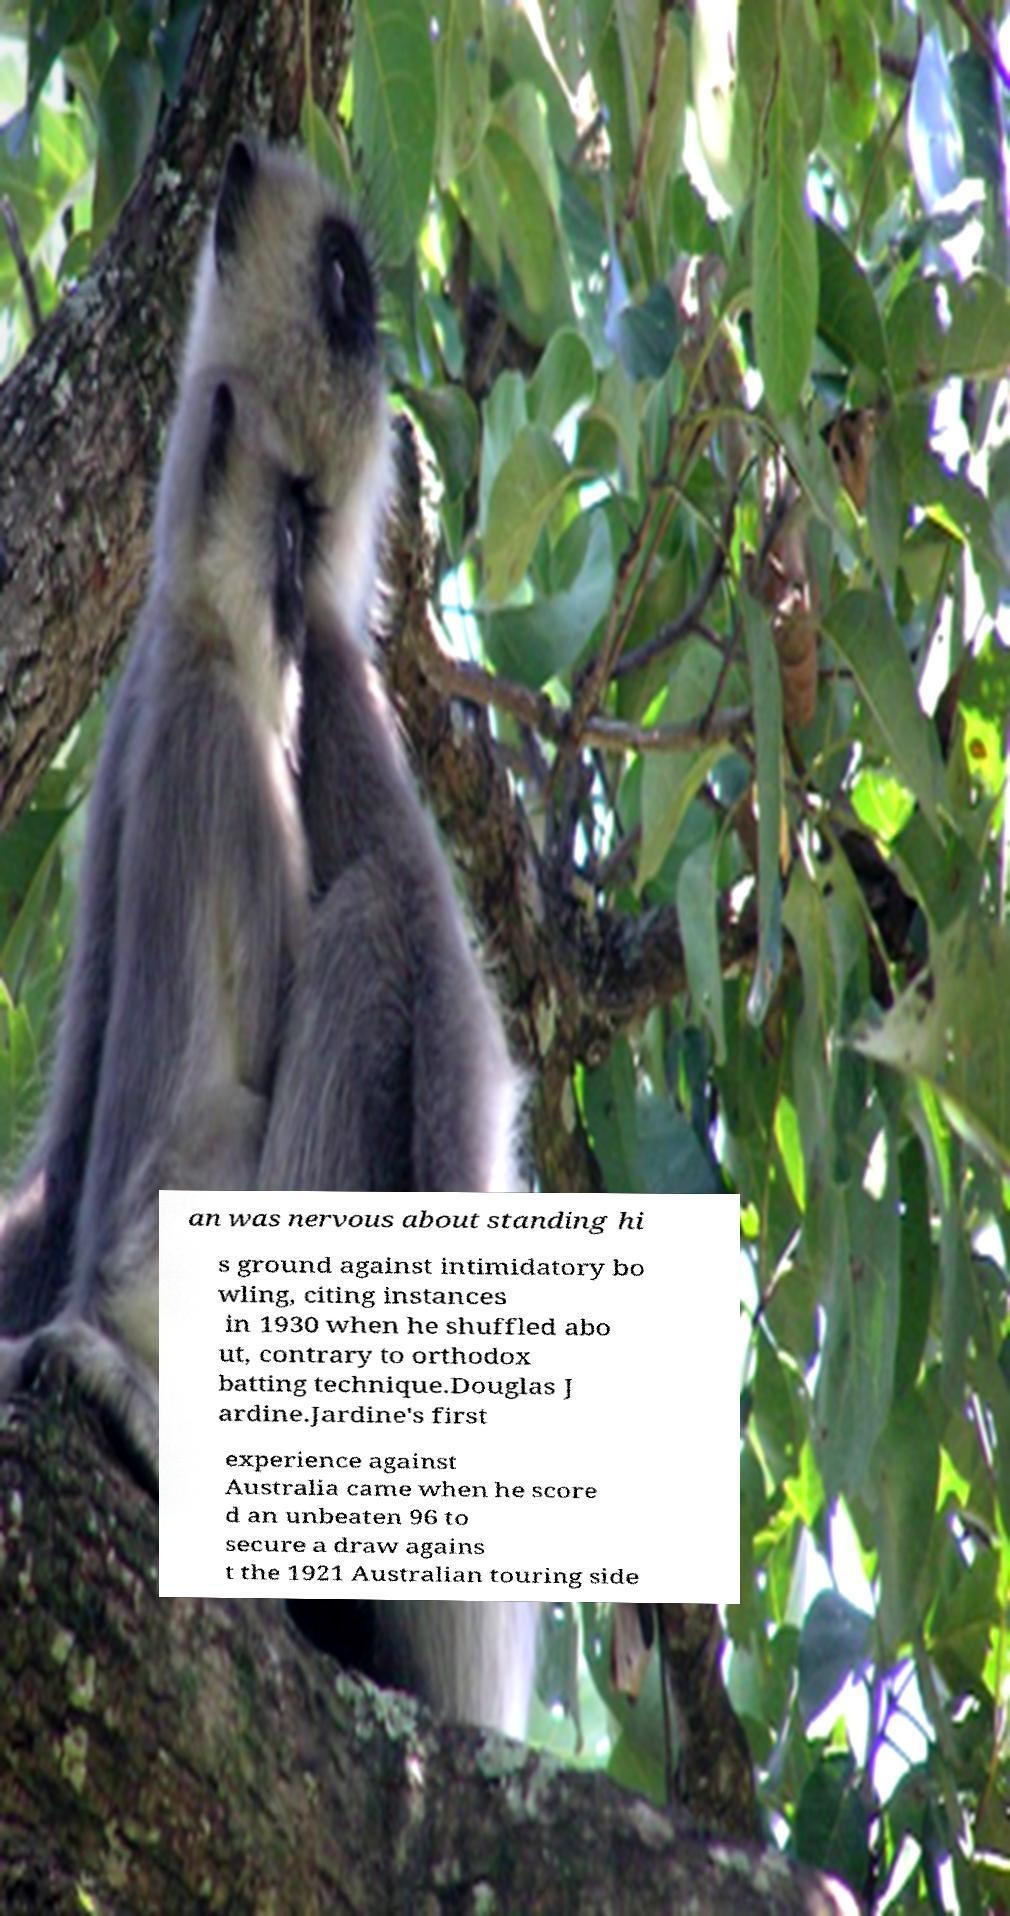What messages or text are displayed in this image? I need them in a readable, typed format. an was nervous about standing hi s ground against intimidatory bo wling, citing instances in 1930 when he shuffled abo ut, contrary to orthodox batting technique.Douglas J ardine.Jardine's first experience against Australia came when he score d an unbeaten 96 to secure a draw agains t the 1921 Australian touring side 